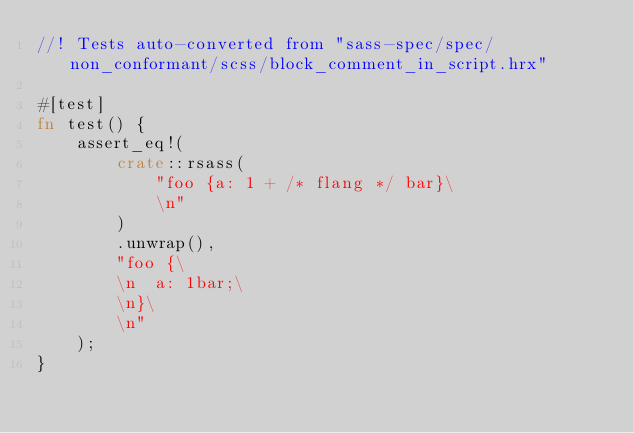<code> <loc_0><loc_0><loc_500><loc_500><_Rust_>//! Tests auto-converted from "sass-spec/spec/non_conformant/scss/block_comment_in_script.hrx"

#[test]
fn test() {
    assert_eq!(
        crate::rsass(
            "foo {a: 1 + /* flang */ bar}\
            \n"
        )
        .unwrap(),
        "foo {\
        \n  a: 1bar;\
        \n}\
        \n"
    );
}
</code> 